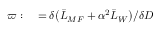<formula> <loc_0><loc_0><loc_500><loc_500>\begin{array} { r l } { \varpi \colon } & = \delta \left ( \ B a r { L } _ { M F } + \alpha ^ { 2 } \ B a r { L } _ { W } \right ) / \delta D } \end{array}</formula> 